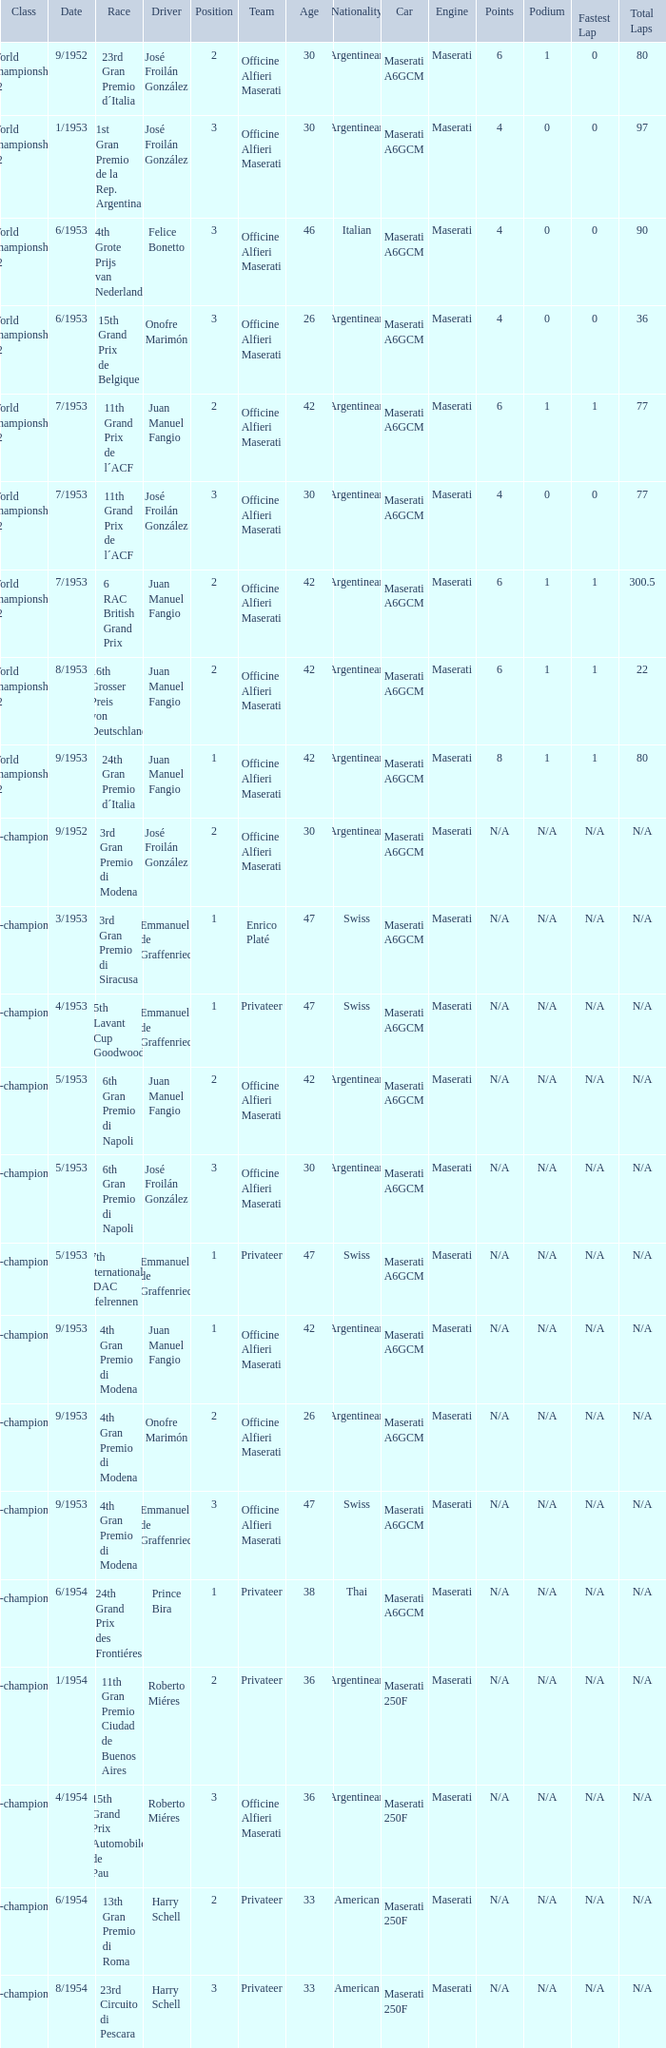What class has the date of 8/1954? Non-championship F1. 